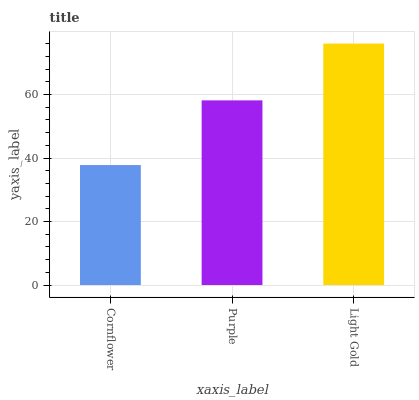Is Cornflower the minimum?
Answer yes or no. Yes. Is Light Gold the maximum?
Answer yes or no. Yes. Is Purple the minimum?
Answer yes or no. No. Is Purple the maximum?
Answer yes or no. No. Is Purple greater than Cornflower?
Answer yes or no. Yes. Is Cornflower less than Purple?
Answer yes or no. Yes. Is Cornflower greater than Purple?
Answer yes or no. No. Is Purple less than Cornflower?
Answer yes or no. No. Is Purple the high median?
Answer yes or no. Yes. Is Purple the low median?
Answer yes or no. Yes. Is Cornflower the high median?
Answer yes or no. No. Is Cornflower the low median?
Answer yes or no. No. 